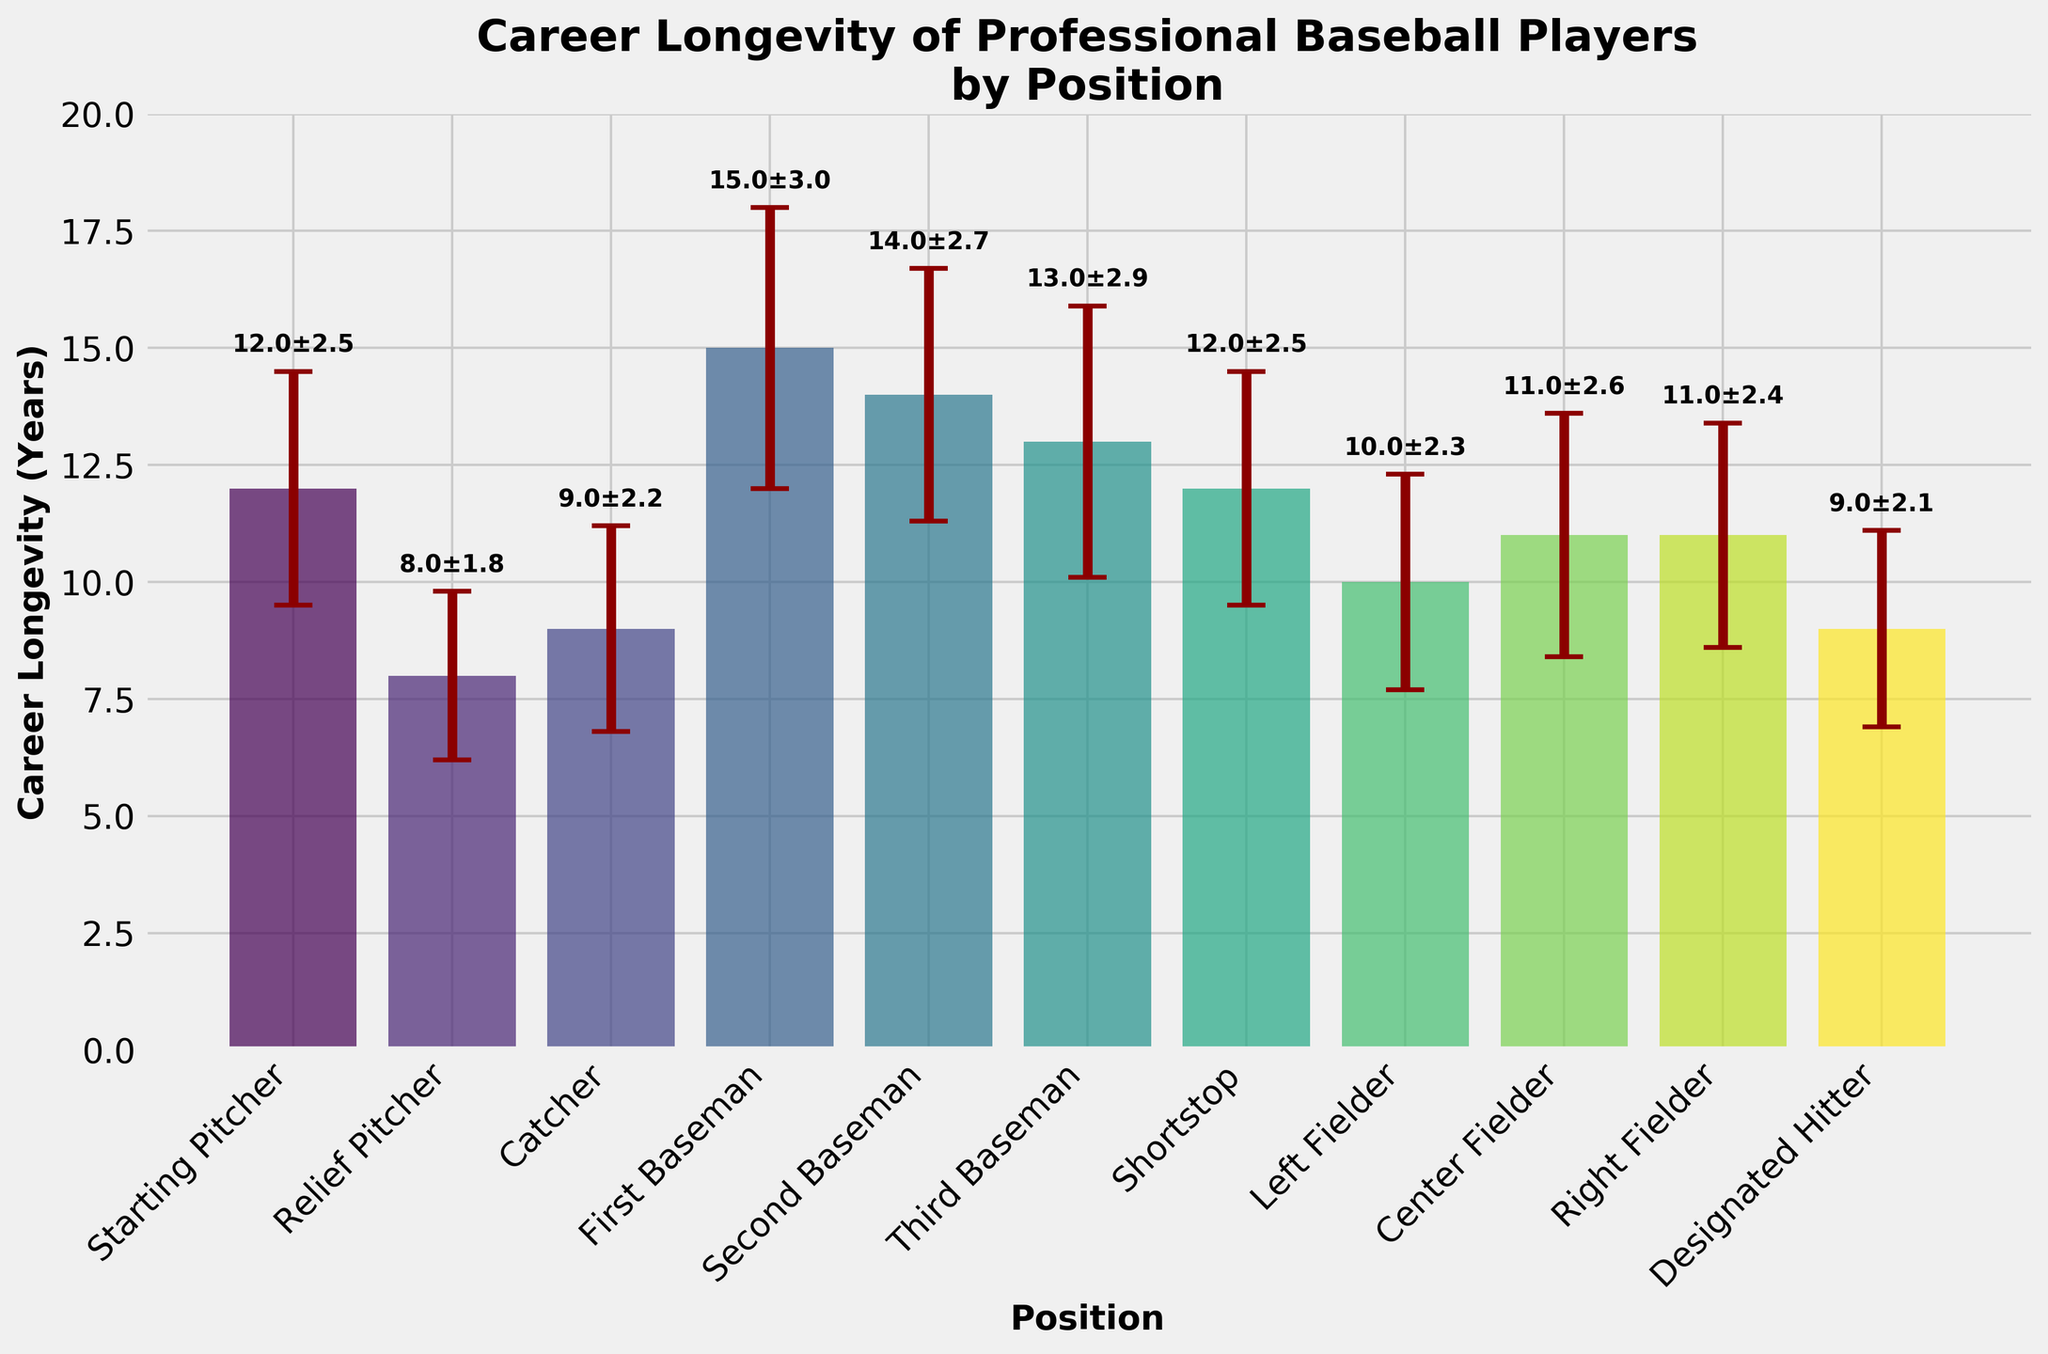What is the title of the figure? The title of the figure is prominently displayed at the top center. It reads "Career Longevity of Professional Baseball Players by Position".
Answer: Career Longevity of Professional Baseball Players by Position Which position has the longest average career longevity according to the figure? The heights of the bars represent average career longevity. The bar for the First Baseman is the tallest, indicating the longest average career longevity.
Answer: First Baseman What is the career longevity and standard deviation for the Relief Pitcher? The Relief Pitcher bar has an error bar extending around the mean longevity. Refer to the label above the bar: it reads "8.0±1.8". Thus, the career longevity is 8 years with a standard deviation of 1.8 years.
Answer: 8 years, 1.8 years Which positions have the same average career longevity? By comparing the heights of the bars, it is observed that the bars for Starting Pitcher and Shortstop are of equal height, each indicating an average career longevity of 12 years.
Answer: Starting Pitcher, Shortstop How much longer, on average, does a First Baseman play compared to a Catcher? The First Baseman's bar indicates a career longevity of 15 years, while the Catcher's bar shows 9 years. Subtracting these values (15 - 9) gives 6 years.
Answer: 6 years What is the range of career longevity shown in the figure? The shortest average career longevity is for the Relief Pitcher at 8 years, and the longest is for the First Baseman at 15 years. The range is found by subtracting these values (15 - 8).
Answer: 7 years Which position has the highest variability in career longevity? The standard deviation is represented by the error bars' caps. The First Baseman has the largest error bar with a standard deviation of 3 years, indicating the highest variability.
Answer: First Baseman What is the combined average career longevity of all positions? Summing the average career longevity of all positions (12 + 8 + 9 + 15 + 14 + 13 + 12 + 10 + 11 + 11 + 9) and dividing by the number of positions (11) gives the combined average. (124/11).
Answer: 11.3 years How does the variability of the Designated Hitter compare to the variability of the Shortstop? The standard deviation of the Designated Hitter is 2.1 years, while that of the Shortstop is 2.5 years. Since 2.1 is less than 2.5, the Designated Hitter has lower variability.
Answer: Lower Are the average career longevities for Corner Infielders higher, lower, or equal to outfield players collectively? Corner Infielders include First, Second, and Third Basemen. Their average career longevity is (15+14+13)/3 = 14 years. Outfielders (Left, Center, Right Fielders) have average longevities of (10+11+11)/3 ≈ 10.7 years. Comparing these averages, Corner Infielders have higher career longevity.
Answer: Higher 